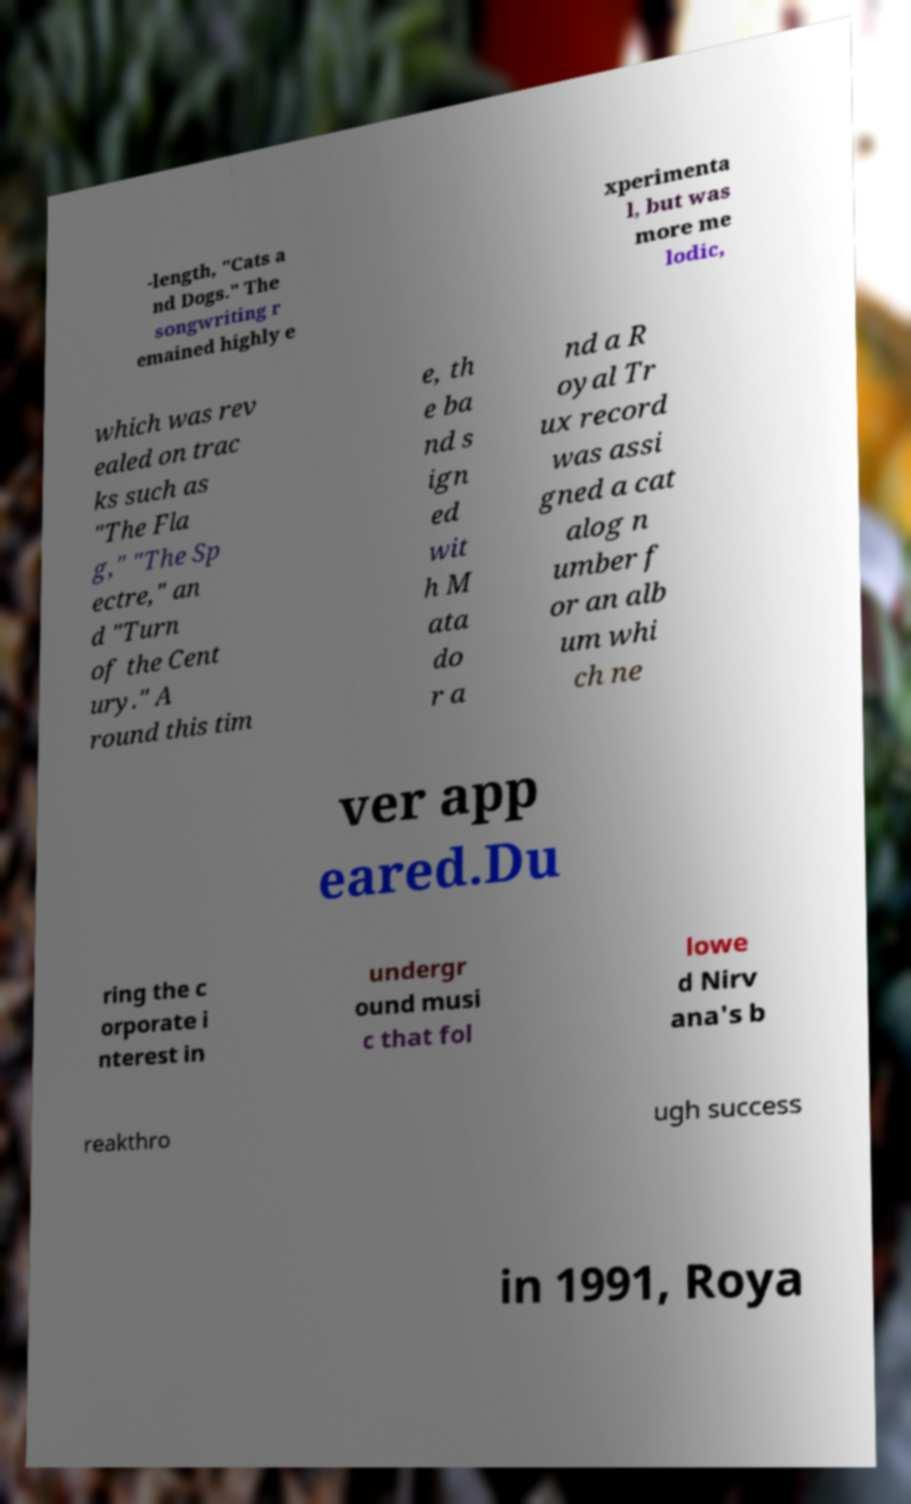For documentation purposes, I need the text within this image transcribed. Could you provide that? -length, "Cats a nd Dogs." The songwriting r emained highly e xperimenta l, but was more me lodic, which was rev ealed on trac ks such as "The Fla g," "The Sp ectre," an d "Turn of the Cent ury." A round this tim e, th e ba nd s ign ed wit h M ata do r a nd a R oyal Tr ux record was assi gned a cat alog n umber f or an alb um whi ch ne ver app eared.Du ring the c orporate i nterest in undergr ound musi c that fol lowe d Nirv ana's b reakthro ugh success in 1991, Roya 